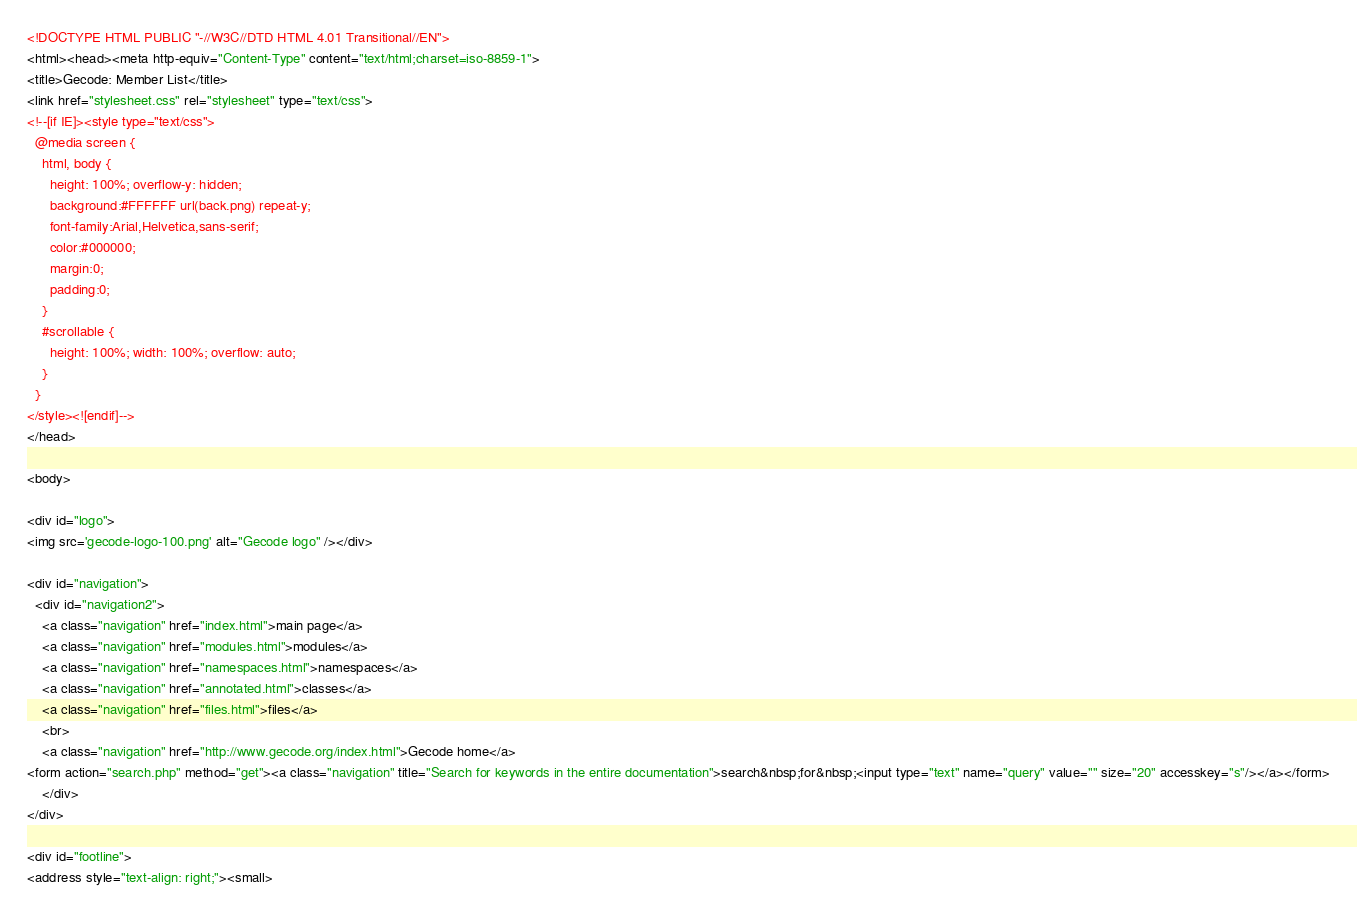Convert code to text. <code><loc_0><loc_0><loc_500><loc_500><_HTML_><!DOCTYPE HTML PUBLIC "-//W3C//DTD HTML 4.01 Transitional//EN">
<html><head><meta http-equiv="Content-Type" content="text/html;charset=iso-8859-1">
<title>Gecode: Member List</title>
<link href="stylesheet.css" rel="stylesheet" type="text/css">
<!--[if IE]><style type="text/css">
  @media screen {
    html, body {
      height: 100%; overflow-y: hidden;
      background:#FFFFFF url(back.png) repeat-y;
      font-family:Arial,Helvetica,sans-serif;
      color:#000000;
      margin:0;
      padding:0;
    }
    #scrollable {
      height: 100%; width: 100%; overflow: auto;
    }
  }
</style><![endif]-->
</head>

<body>

<div id="logo">
<img src='gecode-logo-100.png' alt="Gecode logo" /></div>

<div id="navigation">
  <div id="navigation2">
    <a class="navigation" href="index.html">main page</a>
    <a class="navigation" href="modules.html">modules</a>
    <a class="navigation" href="namespaces.html">namespaces</a>
    <a class="navigation" href="annotated.html">classes</a>
    <a class="navigation" href="files.html">files</a>
    <br>
    <a class="navigation" href="http://www.gecode.org/index.html">Gecode home</a>
<form action="search.php" method="get"><a class="navigation" title="Search for keywords in the entire documentation">search&nbsp;for&nbsp;<input type="text" name="query" value="" size="20" accesskey="s"/></a></form>
    </div>
</div>

<div id="footline">
<address style="text-align: right;"><small></code> 